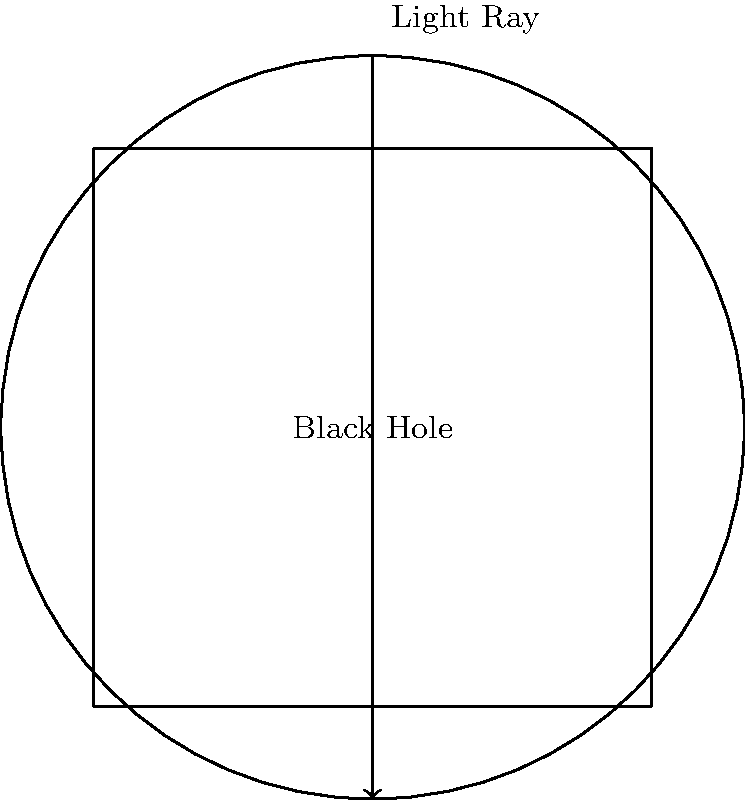In the context of non-Euclidean geometry near a black hole, as shown in the diagram, how does the path of a light ray (represented by the vertical arrow) differ from what would be expected in Euclidean space? Consider implementing this concept in a Kotlin-based Android app that simulates gravitational lensing. To understand the behavior of light rays near a black hole and implement it in a Kotlin-based Android app, we need to consider the following steps:

1. In Euclidean space, light travels in straight lines. However, near a black hole, space-time is curved due to the intense gravitational field.

2. The curvature of space-time causes light rays to bend around the black hole, a phenomenon known as gravitational lensing.

3. In the diagram, the black circle represents the event horizon of the black hole. The light ray, represented by the vertical arrow, would actually follow a curved path around the black hole instead of a straight line.

4. The degree of bending depends on how close the light ray passes to the black hole. Rays passing closer to the black hole will bend more sharply.

5. In extreme cases, light rays that pass very close to the black hole can orbit it multiple times before escaping or being captured.

6. To implement this in a Kotlin-based Android app:
   a. Use custom View or Canvas to draw the scene.
   b. Implement a physics engine to calculate the path of light rays based on the gravitational field.
   c. Use Kotlin's coroutines for smooth animations of light ray paths.
   d. Allow user interaction to adjust parameters like black hole mass or initial light ray direction.

7. The mathematical representation of this curvature is described by Einstein's field equations:

   $$G_{\mu\nu} + \Lambda g_{\mu\nu} = \frac{8\pi G}{c^4} T_{\mu\nu}$$

   Where $G_{\mu\nu}$ is the Einstein tensor, $\Lambda$ is the cosmological constant, $g_{\mu\nu}$ is the metric tensor, $G$ is Newton's gravitational constant, $c$ is the speed of light, and $T_{\mu\nu}$ is the stress-energy tensor.

8. For practical implementation, you would use simplified models and numerical approximations of these equations to calculate light ray paths efficiently on a mobile device.
Answer: Curved path due to gravitational lensing 